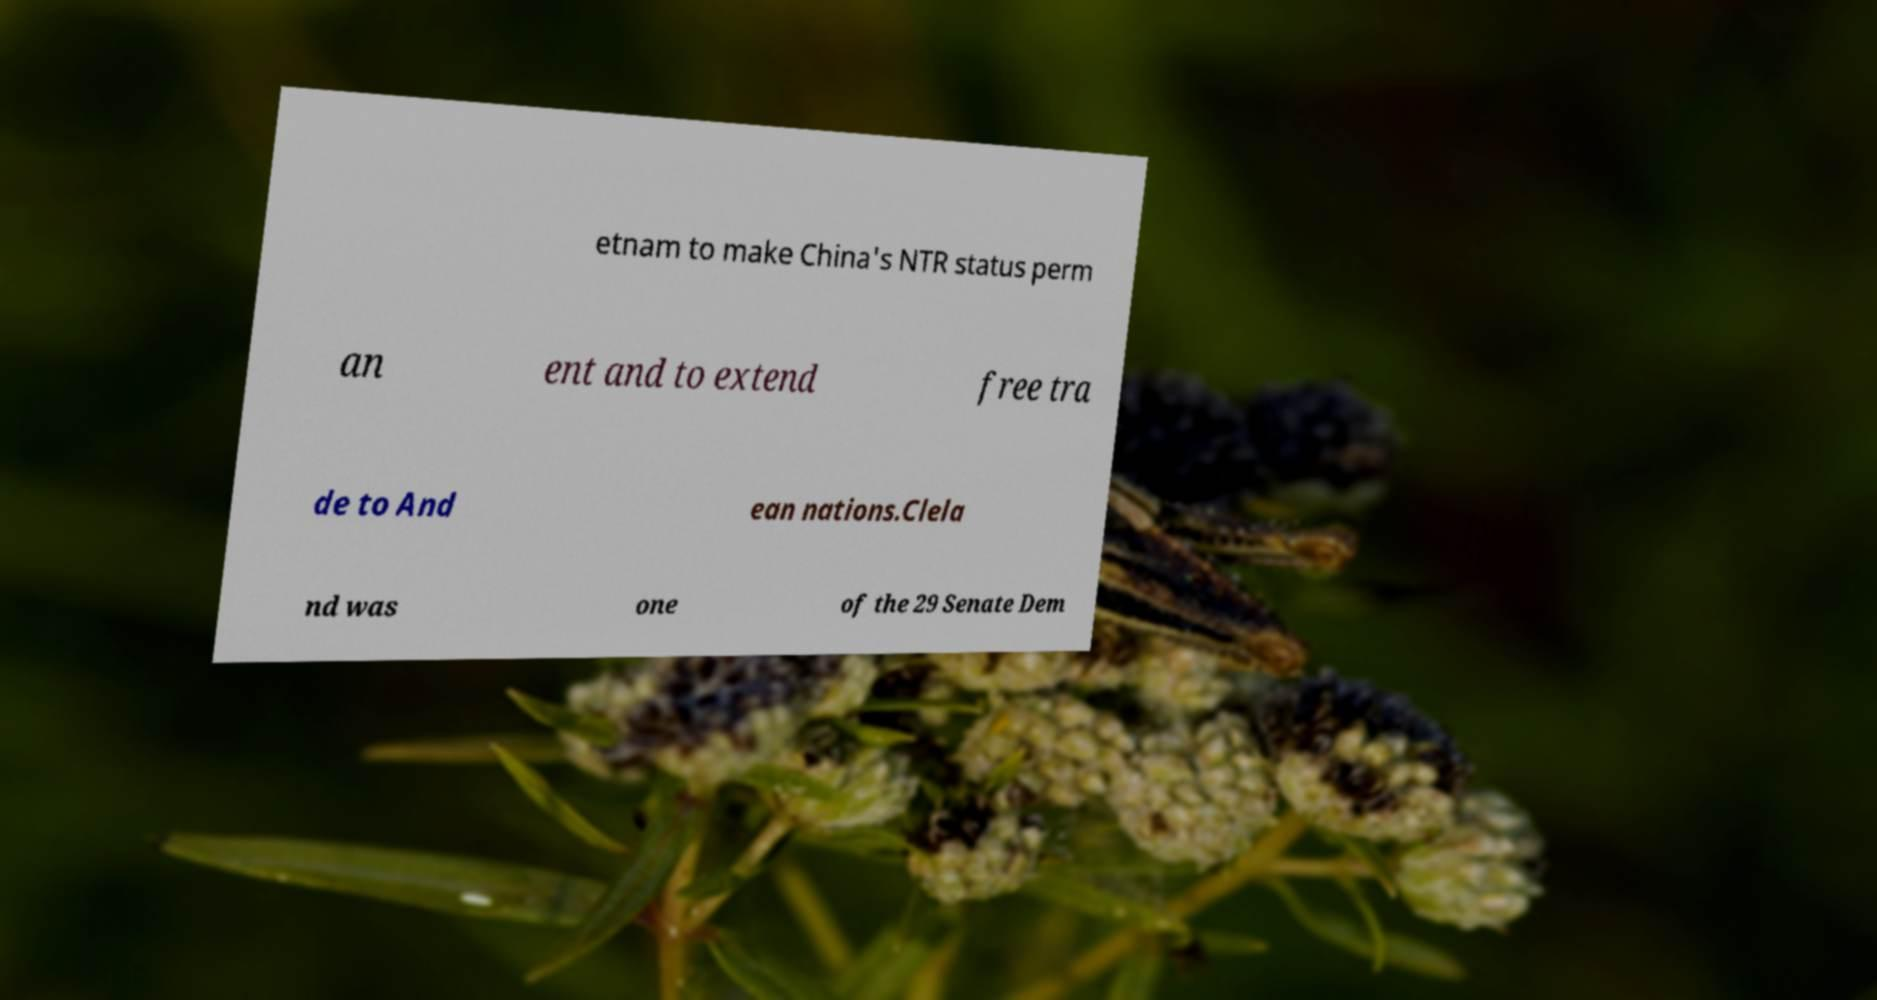Can you accurately transcribe the text from the provided image for me? etnam to make China's NTR status perm an ent and to extend free tra de to And ean nations.Clela nd was one of the 29 Senate Dem 